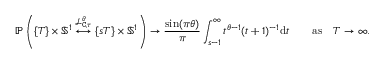<formula> <loc_0><loc_0><loc_500><loc_500>\mathbb { P } \left ( \{ T \} \times \mathbb { S } ^ { 1 } \overset { \mathcal { L } _ { C , \tau } ^ { \theta } } { \longleftrightarrow } \{ s T \} \times \mathbb { S } ^ { 1 } \right ) \to \frac { \sin ( \pi \theta ) } { \pi } \int _ { s - 1 } ^ { \infty } t ^ { \theta - 1 } ( t + 1 ) ^ { - 1 } d t \quad a s \quad T \to \infty .</formula> 